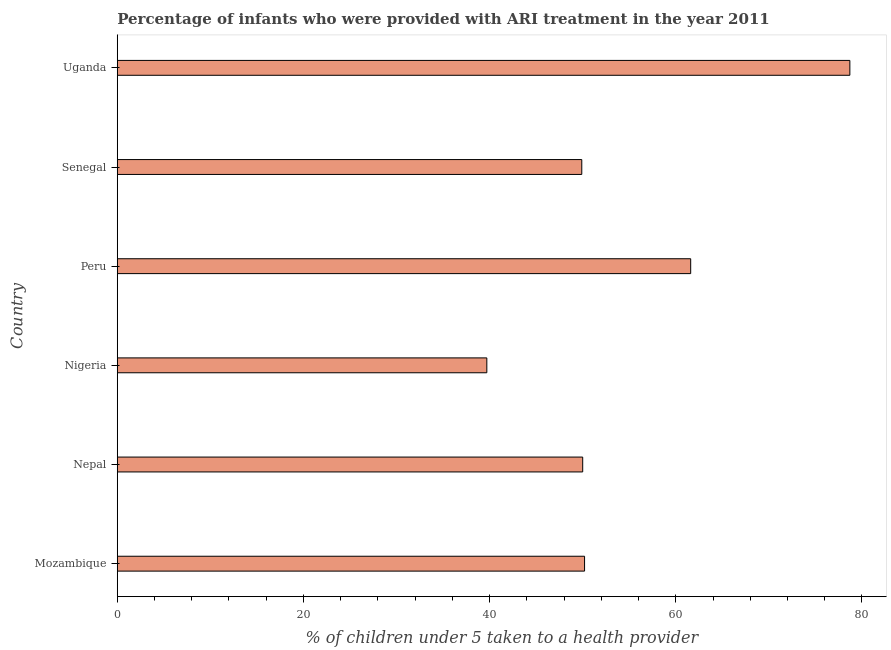Does the graph contain any zero values?
Your response must be concise. No. Does the graph contain grids?
Offer a very short reply. No. What is the title of the graph?
Ensure brevity in your answer.  Percentage of infants who were provided with ARI treatment in the year 2011. What is the label or title of the X-axis?
Your answer should be very brief. % of children under 5 taken to a health provider. Across all countries, what is the maximum percentage of children who were provided with ari treatment?
Offer a very short reply. 78.7. Across all countries, what is the minimum percentage of children who were provided with ari treatment?
Your answer should be compact. 39.7. In which country was the percentage of children who were provided with ari treatment maximum?
Offer a terse response. Uganda. In which country was the percentage of children who were provided with ari treatment minimum?
Make the answer very short. Nigeria. What is the sum of the percentage of children who were provided with ari treatment?
Your answer should be compact. 330.1. What is the difference between the percentage of children who were provided with ari treatment in Nepal and Uganda?
Provide a short and direct response. -28.7. What is the average percentage of children who were provided with ari treatment per country?
Offer a very short reply. 55.02. What is the median percentage of children who were provided with ari treatment?
Provide a short and direct response. 50.1. In how many countries, is the percentage of children who were provided with ari treatment greater than 16 %?
Make the answer very short. 6. What is the ratio of the percentage of children who were provided with ari treatment in Peru to that in Uganda?
Your response must be concise. 0.78. What is the difference between the highest and the second highest percentage of children who were provided with ari treatment?
Offer a terse response. 17.1. Are all the bars in the graph horizontal?
Provide a short and direct response. Yes. What is the difference between two consecutive major ticks on the X-axis?
Offer a terse response. 20. Are the values on the major ticks of X-axis written in scientific E-notation?
Your response must be concise. No. What is the % of children under 5 taken to a health provider in Mozambique?
Your response must be concise. 50.2. What is the % of children under 5 taken to a health provider of Nigeria?
Ensure brevity in your answer.  39.7. What is the % of children under 5 taken to a health provider of Peru?
Make the answer very short. 61.6. What is the % of children under 5 taken to a health provider in Senegal?
Offer a very short reply. 49.9. What is the % of children under 5 taken to a health provider in Uganda?
Your answer should be compact. 78.7. What is the difference between the % of children under 5 taken to a health provider in Mozambique and Nepal?
Offer a very short reply. 0.2. What is the difference between the % of children under 5 taken to a health provider in Mozambique and Nigeria?
Make the answer very short. 10.5. What is the difference between the % of children under 5 taken to a health provider in Mozambique and Peru?
Offer a very short reply. -11.4. What is the difference between the % of children under 5 taken to a health provider in Mozambique and Uganda?
Give a very brief answer. -28.5. What is the difference between the % of children under 5 taken to a health provider in Nepal and Peru?
Make the answer very short. -11.6. What is the difference between the % of children under 5 taken to a health provider in Nepal and Uganda?
Make the answer very short. -28.7. What is the difference between the % of children under 5 taken to a health provider in Nigeria and Peru?
Your answer should be compact. -21.9. What is the difference between the % of children under 5 taken to a health provider in Nigeria and Senegal?
Offer a very short reply. -10.2. What is the difference between the % of children under 5 taken to a health provider in Nigeria and Uganda?
Keep it short and to the point. -39. What is the difference between the % of children under 5 taken to a health provider in Peru and Senegal?
Keep it short and to the point. 11.7. What is the difference between the % of children under 5 taken to a health provider in Peru and Uganda?
Give a very brief answer. -17.1. What is the difference between the % of children under 5 taken to a health provider in Senegal and Uganda?
Provide a short and direct response. -28.8. What is the ratio of the % of children under 5 taken to a health provider in Mozambique to that in Nepal?
Offer a very short reply. 1. What is the ratio of the % of children under 5 taken to a health provider in Mozambique to that in Nigeria?
Offer a very short reply. 1.26. What is the ratio of the % of children under 5 taken to a health provider in Mozambique to that in Peru?
Your response must be concise. 0.81. What is the ratio of the % of children under 5 taken to a health provider in Mozambique to that in Senegal?
Keep it short and to the point. 1.01. What is the ratio of the % of children under 5 taken to a health provider in Mozambique to that in Uganda?
Make the answer very short. 0.64. What is the ratio of the % of children under 5 taken to a health provider in Nepal to that in Nigeria?
Your response must be concise. 1.26. What is the ratio of the % of children under 5 taken to a health provider in Nepal to that in Peru?
Give a very brief answer. 0.81. What is the ratio of the % of children under 5 taken to a health provider in Nepal to that in Uganda?
Provide a succinct answer. 0.64. What is the ratio of the % of children under 5 taken to a health provider in Nigeria to that in Peru?
Keep it short and to the point. 0.64. What is the ratio of the % of children under 5 taken to a health provider in Nigeria to that in Senegal?
Make the answer very short. 0.8. What is the ratio of the % of children under 5 taken to a health provider in Nigeria to that in Uganda?
Offer a very short reply. 0.5. What is the ratio of the % of children under 5 taken to a health provider in Peru to that in Senegal?
Ensure brevity in your answer.  1.23. What is the ratio of the % of children under 5 taken to a health provider in Peru to that in Uganda?
Ensure brevity in your answer.  0.78. What is the ratio of the % of children under 5 taken to a health provider in Senegal to that in Uganda?
Keep it short and to the point. 0.63. 